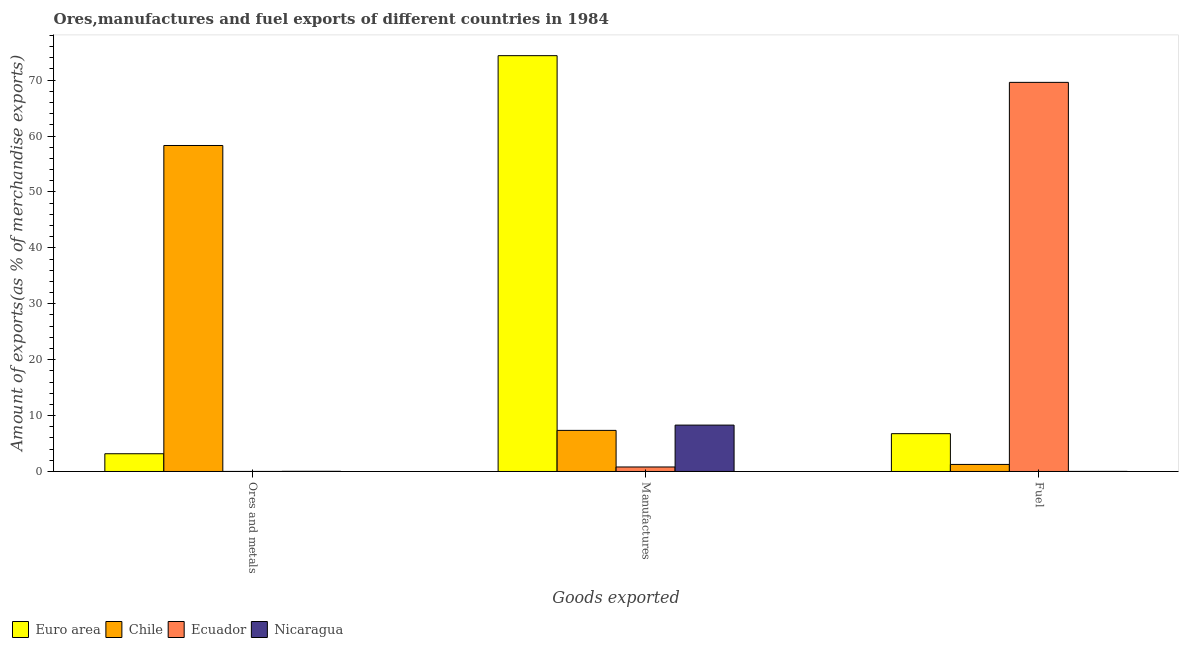How many groups of bars are there?
Offer a very short reply. 3. Are the number of bars on each tick of the X-axis equal?
Give a very brief answer. Yes. How many bars are there on the 2nd tick from the right?
Give a very brief answer. 4. What is the label of the 3rd group of bars from the left?
Make the answer very short. Fuel. What is the percentage of ores and metals exports in Chile?
Your response must be concise. 58.31. Across all countries, what is the maximum percentage of manufactures exports?
Give a very brief answer. 74.38. Across all countries, what is the minimum percentage of fuel exports?
Give a very brief answer. 0.02. In which country was the percentage of manufactures exports maximum?
Provide a short and direct response. Euro area. In which country was the percentage of ores and metals exports minimum?
Your response must be concise. Ecuador. What is the total percentage of ores and metals exports in the graph?
Offer a very short reply. 61.53. What is the difference between the percentage of manufactures exports in Euro area and that in Chile?
Ensure brevity in your answer.  67.02. What is the difference between the percentage of manufactures exports in Chile and the percentage of fuel exports in Euro area?
Ensure brevity in your answer.  0.59. What is the average percentage of fuel exports per country?
Keep it short and to the point. 19.41. What is the difference between the percentage of manufactures exports and percentage of ores and metals exports in Ecuador?
Offer a terse response. 0.79. What is the ratio of the percentage of ores and metals exports in Euro area to that in Nicaragua?
Give a very brief answer. 95.08. Is the percentage of fuel exports in Ecuador less than that in Chile?
Ensure brevity in your answer.  No. Is the difference between the percentage of ores and metals exports in Chile and Ecuador greater than the difference between the percentage of manufactures exports in Chile and Ecuador?
Your answer should be compact. Yes. What is the difference between the highest and the second highest percentage of fuel exports?
Your answer should be very brief. 62.83. What is the difference between the highest and the lowest percentage of fuel exports?
Offer a terse response. 69.59. Is the sum of the percentage of manufactures exports in Ecuador and Nicaragua greater than the maximum percentage of fuel exports across all countries?
Provide a succinct answer. No. What does the 3rd bar from the left in Fuel represents?
Provide a succinct answer. Ecuador. What does the 1st bar from the right in Manufactures represents?
Your answer should be very brief. Nicaragua. How many countries are there in the graph?
Ensure brevity in your answer.  4. What is the difference between two consecutive major ticks on the Y-axis?
Your response must be concise. 10. Does the graph contain any zero values?
Offer a very short reply. No. Does the graph contain grids?
Offer a very short reply. No. How many legend labels are there?
Offer a very short reply. 4. What is the title of the graph?
Your response must be concise. Ores,manufactures and fuel exports of different countries in 1984. What is the label or title of the X-axis?
Offer a very short reply. Goods exported. What is the label or title of the Y-axis?
Offer a terse response. Amount of exports(as % of merchandise exports). What is the Amount of exports(as % of merchandise exports) in Euro area in Ores and metals?
Keep it short and to the point. 3.17. What is the Amount of exports(as % of merchandise exports) in Chile in Ores and metals?
Offer a terse response. 58.31. What is the Amount of exports(as % of merchandise exports) in Ecuador in Ores and metals?
Your answer should be compact. 0.01. What is the Amount of exports(as % of merchandise exports) of Nicaragua in Ores and metals?
Your answer should be very brief. 0.03. What is the Amount of exports(as % of merchandise exports) in Euro area in Manufactures?
Your answer should be compact. 74.38. What is the Amount of exports(as % of merchandise exports) in Chile in Manufactures?
Provide a succinct answer. 7.35. What is the Amount of exports(as % of merchandise exports) in Ecuador in Manufactures?
Your response must be concise. 0.81. What is the Amount of exports(as % of merchandise exports) of Nicaragua in Manufactures?
Your answer should be very brief. 8.3. What is the Amount of exports(as % of merchandise exports) in Euro area in Fuel?
Keep it short and to the point. 6.77. What is the Amount of exports(as % of merchandise exports) in Chile in Fuel?
Provide a short and direct response. 1.26. What is the Amount of exports(as % of merchandise exports) in Ecuador in Fuel?
Offer a terse response. 69.6. What is the Amount of exports(as % of merchandise exports) in Nicaragua in Fuel?
Provide a succinct answer. 0.02. Across all Goods exported, what is the maximum Amount of exports(as % of merchandise exports) of Euro area?
Ensure brevity in your answer.  74.38. Across all Goods exported, what is the maximum Amount of exports(as % of merchandise exports) of Chile?
Provide a succinct answer. 58.31. Across all Goods exported, what is the maximum Amount of exports(as % of merchandise exports) in Ecuador?
Your answer should be very brief. 69.6. Across all Goods exported, what is the maximum Amount of exports(as % of merchandise exports) of Nicaragua?
Offer a very short reply. 8.3. Across all Goods exported, what is the minimum Amount of exports(as % of merchandise exports) in Euro area?
Offer a very short reply. 3.17. Across all Goods exported, what is the minimum Amount of exports(as % of merchandise exports) in Chile?
Offer a terse response. 1.26. Across all Goods exported, what is the minimum Amount of exports(as % of merchandise exports) in Ecuador?
Make the answer very short. 0.01. Across all Goods exported, what is the minimum Amount of exports(as % of merchandise exports) in Nicaragua?
Your response must be concise. 0.02. What is the total Amount of exports(as % of merchandise exports) of Euro area in the graph?
Keep it short and to the point. 84.32. What is the total Amount of exports(as % of merchandise exports) in Chile in the graph?
Your answer should be compact. 66.93. What is the total Amount of exports(as % of merchandise exports) of Ecuador in the graph?
Ensure brevity in your answer.  70.42. What is the total Amount of exports(as % of merchandise exports) in Nicaragua in the graph?
Give a very brief answer. 8.35. What is the difference between the Amount of exports(as % of merchandise exports) in Euro area in Ores and metals and that in Manufactures?
Ensure brevity in your answer.  -71.21. What is the difference between the Amount of exports(as % of merchandise exports) in Chile in Ores and metals and that in Manufactures?
Your answer should be very brief. 50.96. What is the difference between the Amount of exports(as % of merchandise exports) in Ecuador in Ores and metals and that in Manufactures?
Keep it short and to the point. -0.79. What is the difference between the Amount of exports(as % of merchandise exports) in Nicaragua in Ores and metals and that in Manufactures?
Your answer should be very brief. -8.26. What is the difference between the Amount of exports(as % of merchandise exports) of Euro area in Ores and metals and that in Fuel?
Provide a short and direct response. -3.59. What is the difference between the Amount of exports(as % of merchandise exports) of Chile in Ores and metals and that in Fuel?
Offer a very short reply. 57.05. What is the difference between the Amount of exports(as % of merchandise exports) in Ecuador in Ores and metals and that in Fuel?
Ensure brevity in your answer.  -69.59. What is the difference between the Amount of exports(as % of merchandise exports) of Nicaragua in Ores and metals and that in Fuel?
Give a very brief answer. 0.02. What is the difference between the Amount of exports(as % of merchandise exports) in Euro area in Manufactures and that in Fuel?
Keep it short and to the point. 67.61. What is the difference between the Amount of exports(as % of merchandise exports) of Chile in Manufactures and that in Fuel?
Your answer should be compact. 6.09. What is the difference between the Amount of exports(as % of merchandise exports) in Ecuador in Manufactures and that in Fuel?
Your answer should be compact. -68.8. What is the difference between the Amount of exports(as % of merchandise exports) in Nicaragua in Manufactures and that in Fuel?
Your answer should be compact. 8.28. What is the difference between the Amount of exports(as % of merchandise exports) in Euro area in Ores and metals and the Amount of exports(as % of merchandise exports) in Chile in Manufactures?
Give a very brief answer. -4.18. What is the difference between the Amount of exports(as % of merchandise exports) in Euro area in Ores and metals and the Amount of exports(as % of merchandise exports) in Ecuador in Manufactures?
Your answer should be very brief. 2.37. What is the difference between the Amount of exports(as % of merchandise exports) of Euro area in Ores and metals and the Amount of exports(as % of merchandise exports) of Nicaragua in Manufactures?
Provide a short and direct response. -5.12. What is the difference between the Amount of exports(as % of merchandise exports) of Chile in Ores and metals and the Amount of exports(as % of merchandise exports) of Ecuador in Manufactures?
Your response must be concise. 57.51. What is the difference between the Amount of exports(as % of merchandise exports) of Chile in Ores and metals and the Amount of exports(as % of merchandise exports) of Nicaragua in Manufactures?
Keep it short and to the point. 50.01. What is the difference between the Amount of exports(as % of merchandise exports) of Ecuador in Ores and metals and the Amount of exports(as % of merchandise exports) of Nicaragua in Manufactures?
Provide a short and direct response. -8.29. What is the difference between the Amount of exports(as % of merchandise exports) in Euro area in Ores and metals and the Amount of exports(as % of merchandise exports) in Chile in Fuel?
Offer a very short reply. 1.91. What is the difference between the Amount of exports(as % of merchandise exports) of Euro area in Ores and metals and the Amount of exports(as % of merchandise exports) of Ecuador in Fuel?
Provide a succinct answer. -66.43. What is the difference between the Amount of exports(as % of merchandise exports) of Euro area in Ores and metals and the Amount of exports(as % of merchandise exports) of Nicaragua in Fuel?
Keep it short and to the point. 3.16. What is the difference between the Amount of exports(as % of merchandise exports) of Chile in Ores and metals and the Amount of exports(as % of merchandise exports) of Ecuador in Fuel?
Provide a short and direct response. -11.29. What is the difference between the Amount of exports(as % of merchandise exports) in Chile in Ores and metals and the Amount of exports(as % of merchandise exports) in Nicaragua in Fuel?
Your answer should be compact. 58.29. What is the difference between the Amount of exports(as % of merchandise exports) of Ecuador in Ores and metals and the Amount of exports(as % of merchandise exports) of Nicaragua in Fuel?
Keep it short and to the point. -0.01. What is the difference between the Amount of exports(as % of merchandise exports) in Euro area in Manufactures and the Amount of exports(as % of merchandise exports) in Chile in Fuel?
Your answer should be compact. 73.11. What is the difference between the Amount of exports(as % of merchandise exports) in Euro area in Manufactures and the Amount of exports(as % of merchandise exports) in Ecuador in Fuel?
Provide a succinct answer. 4.78. What is the difference between the Amount of exports(as % of merchandise exports) of Euro area in Manufactures and the Amount of exports(as % of merchandise exports) of Nicaragua in Fuel?
Offer a very short reply. 74.36. What is the difference between the Amount of exports(as % of merchandise exports) in Chile in Manufactures and the Amount of exports(as % of merchandise exports) in Ecuador in Fuel?
Keep it short and to the point. -62.25. What is the difference between the Amount of exports(as % of merchandise exports) in Chile in Manufactures and the Amount of exports(as % of merchandise exports) in Nicaragua in Fuel?
Offer a terse response. 7.34. What is the difference between the Amount of exports(as % of merchandise exports) of Ecuador in Manufactures and the Amount of exports(as % of merchandise exports) of Nicaragua in Fuel?
Your answer should be compact. 0.79. What is the average Amount of exports(as % of merchandise exports) of Euro area per Goods exported?
Offer a very short reply. 28.11. What is the average Amount of exports(as % of merchandise exports) of Chile per Goods exported?
Your answer should be very brief. 22.31. What is the average Amount of exports(as % of merchandise exports) of Ecuador per Goods exported?
Keep it short and to the point. 23.47. What is the average Amount of exports(as % of merchandise exports) of Nicaragua per Goods exported?
Your response must be concise. 2.78. What is the difference between the Amount of exports(as % of merchandise exports) in Euro area and Amount of exports(as % of merchandise exports) in Chile in Ores and metals?
Give a very brief answer. -55.14. What is the difference between the Amount of exports(as % of merchandise exports) of Euro area and Amount of exports(as % of merchandise exports) of Ecuador in Ores and metals?
Offer a terse response. 3.16. What is the difference between the Amount of exports(as % of merchandise exports) of Euro area and Amount of exports(as % of merchandise exports) of Nicaragua in Ores and metals?
Offer a very short reply. 3.14. What is the difference between the Amount of exports(as % of merchandise exports) in Chile and Amount of exports(as % of merchandise exports) in Ecuador in Ores and metals?
Provide a succinct answer. 58.3. What is the difference between the Amount of exports(as % of merchandise exports) of Chile and Amount of exports(as % of merchandise exports) of Nicaragua in Ores and metals?
Provide a short and direct response. 58.28. What is the difference between the Amount of exports(as % of merchandise exports) of Ecuador and Amount of exports(as % of merchandise exports) of Nicaragua in Ores and metals?
Ensure brevity in your answer.  -0.02. What is the difference between the Amount of exports(as % of merchandise exports) in Euro area and Amount of exports(as % of merchandise exports) in Chile in Manufactures?
Provide a short and direct response. 67.02. What is the difference between the Amount of exports(as % of merchandise exports) of Euro area and Amount of exports(as % of merchandise exports) of Ecuador in Manufactures?
Make the answer very short. 73.57. What is the difference between the Amount of exports(as % of merchandise exports) in Euro area and Amount of exports(as % of merchandise exports) in Nicaragua in Manufactures?
Make the answer very short. 66.08. What is the difference between the Amount of exports(as % of merchandise exports) in Chile and Amount of exports(as % of merchandise exports) in Ecuador in Manufactures?
Provide a short and direct response. 6.55. What is the difference between the Amount of exports(as % of merchandise exports) of Chile and Amount of exports(as % of merchandise exports) of Nicaragua in Manufactures?
Your response must be concise. -0.94. What is the difference between the Amount of exports(as % of merchandise exports) in Ecuador and Amount of exports(as % of merchandise exports) in Nicaragua in Manufactures?
Make the answer very short. -7.49. What is the difference between the Amount of exports(as % of merchandise exports) in Euro area and Amount of exports(as % of merchandise exports) in Chile in Fuel?
Offer a very short reply. 5.5. What is the difference between the Amount of exports(as % of merchandise exports) of Euro area and Amount of exports(as % of merchandise exports) of Ecuador in Fuel?
Provide a short and direct response. -62.83. What is the difference between the Amount of exports(as % of merchandise exports) of Euro area and Amount of exports(as % of merchandise exports) of Nicaragua in Fuel?
Provide a succinct answer. 6.75. What is the difference between the Amount of exports(as % of merchandise exports) in Chile and Amount of exports(as % of merchandise exports) in Ecuador in Fuel?
Ensure brevity in your answer.  -68.34. What is the difference between the Amount of exports(as % of merchandise exports) of Chile and Amount of exports(as % of merchandise exports) of Nicaragua in Fuel?
Provide a succinct answer. 1.25. What is the difference between the Amount of exports(as % of merchandise exports) of Ecuador and Amount of exports(as % of merchandise exports) of Nicaragua in Fuel?
Give a very brief answer. 69.59. What is the ratio of the Amount of exports(as % of merchandise exports) of Euro area in Ores and metals to that in Manufactures?
Keep it short and to the point. 0.04. What is the ratio of the Amount of exports(as % of merchandise exports) in Chile in Ores and metals to that in Manufactures?
Keep it short and to the point. 7.93. What is the ratio of the Amount of exports(as % of merchandise exports) of Ecuador in Ores and metals to that in Manufactures?
Provide a short and direct response. 0.01. What is the ratio of the Amount of exports(as % of merchandise exports) of Nicaragua in Ores and metals to that in Manufactures?
Your answer should be very brief. 0. What is the ratio of the Amount of exports(as % of merchandise exports) of Euro area in Ores and metals to that in Fuel?
Offer a very short reply. 0.47. What is the ratio of the Amount of exports(as % of merchandise exports) in Chile in Ores and metals to that in Fuel?
Provide a succinct answer. 46.18. What is the ratio of the Amount of exports(as % of merchandise exports) of Nicaragua in Ores and metals to that in Fuel?
Your answer should be very brief. 2.19. What is the ratio of the Amount of exports(as % of merchandise exports) of Euro area in Manufactures to that in Fuel?
Offer a terse response. 10.99. What is the ratio of the Amount of exports(as % of merchandise exports) in Chile in Manufactures to that in Fuel?
Make the answer very short. 5.82. What is the ratio of the Amount of exports(as % of merchandise exports) in Ecuador in Manufactures to that in Fuel?
Ensure brevity in your answer.  0.01. What is the ratio of the Amount of exports(as % of merchandise exports) of Nicaragua in Manufactures to that in Fuel?
Make the answer very short. 543.71. What is the difference between the highest and the second highest Amount of exports(as % of merchandise exports) of Euro area?
Provide a short and direct response. 67.61. What is the difference between the highest and the second highest Amount of exports(as % of merchandise exports) of Chile?
Offer a terse response. 50.96. What is the difference between the highest and the second highest Amount of exports(as % of merchandise exports) in Ecuador?
Provide a succinct answer. 68.8. What is the difference between the highest and the second highest Amount of exports(as % of merchandise exports) in Nicaragua?
Offer a terse response. 8.26. What is the difference between the highest and the lowest Amount of exports(as % of merchandise exports) of Euro area?
Your answer should be compact. 71.21. What is the difference between the highest and the lowest Amount of exports(as % of merchandise exports) in Chile?
Offer a very short reply. 57.05. What is the difference between the highest and the lowest Amount of exports(as % of merchandise exports) in Ecuador?
Your answer should be very brief. 69.59. What is the difference between the highest and the lowest Amount of exports(as % of merchandise exports) in Nicaragua?
Provide a succinct answer. 8.28. 